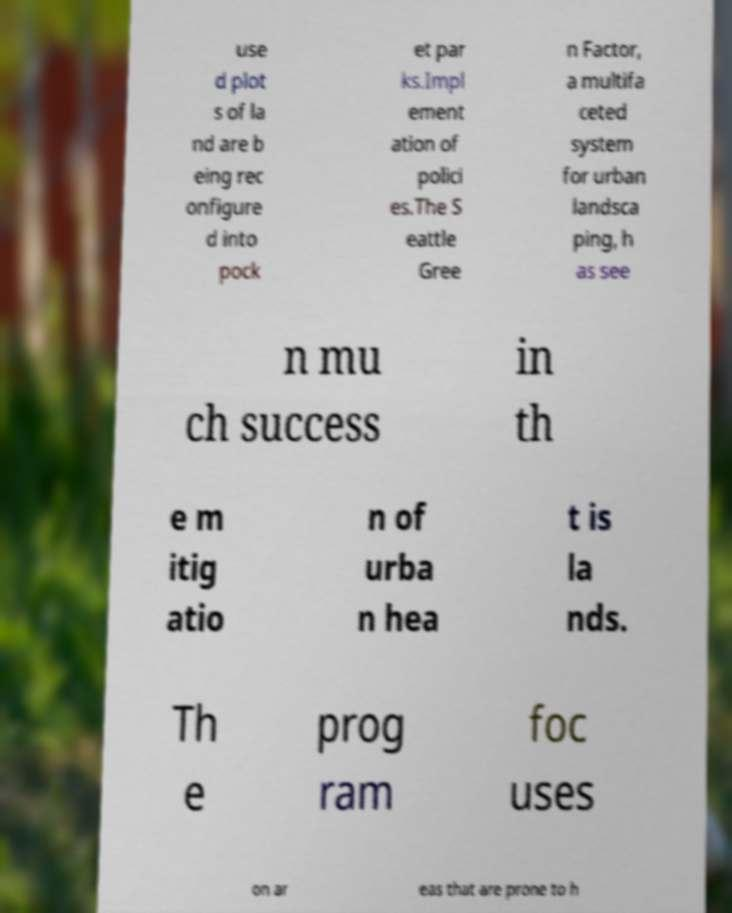Can you read and provide the text displayed in the image?This photo seems to have some interesting text. Can you extract and type it out for me? use d plot s of la nd are b eing rec onfigure d into pock et par ks.Impl ement ation of polici es.The S eattle Gree n Factor, a multifa ceted system for urban landsca ping, h as see n mu ch success in th e m itig atio n of urba n hea t is la nds. Th e prog ram foc uses on ar eas that are prone to h 